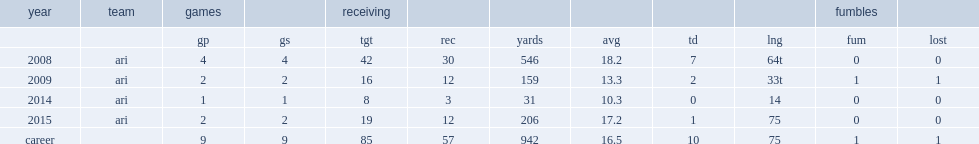How many yards did larry fitzgerald score in 2009? 159.0. How many touchdowns did larry fitzgerald score in 2009? 2.0. 